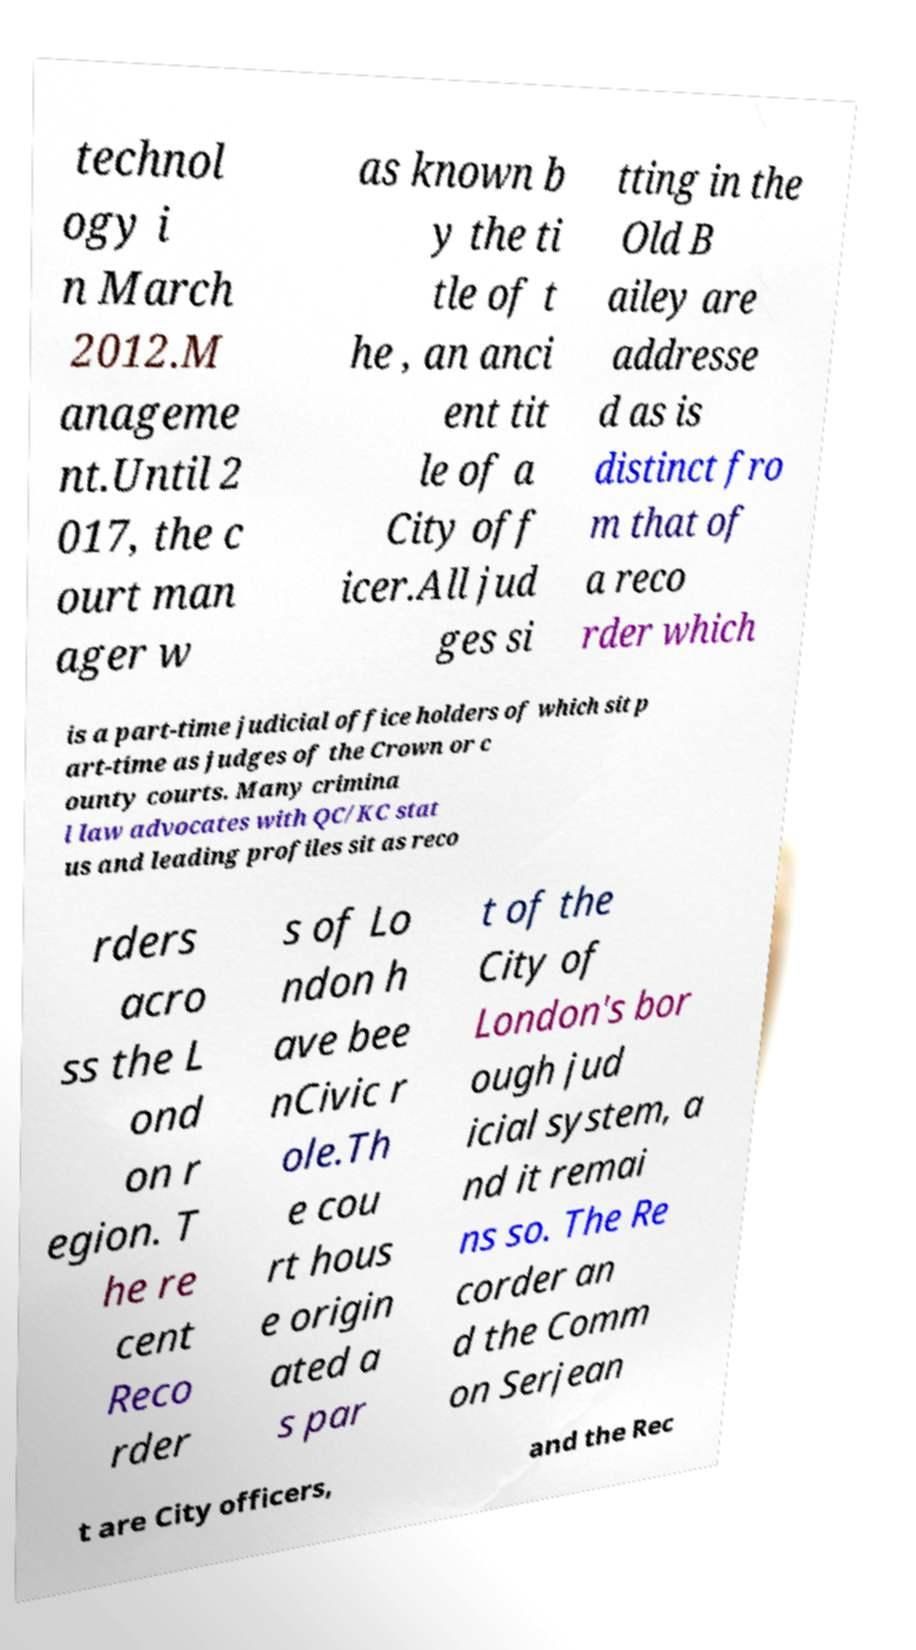Could you extract and type out the text from this image? technol ogy i n March 2012.M anageme nt.Until 2 017, the c ourt man ager w as known b y the ti tle of t he , an anci ent tit le of a City off icer.All jud ges si tting in the Old B ailey are addresse d as is distinct fro m that of a reco rder which is a part-time judicial office holders of which sit p art-time as judges of the Crown or c ounty courts. Many crimina l law advocates with QC/KC stat us and leading profiles sit as reco rders acro ss the L ond on r egion. T he re cent Reco rder s of Lo ndon h ave bee nCivic r ole.Th e cou rt hous e origin ated a s par t of the City of London's bor ough jud icial system, a nd it remai ns so. The Re corder an d the Comm on Serjean t are City officers, and the Rec 